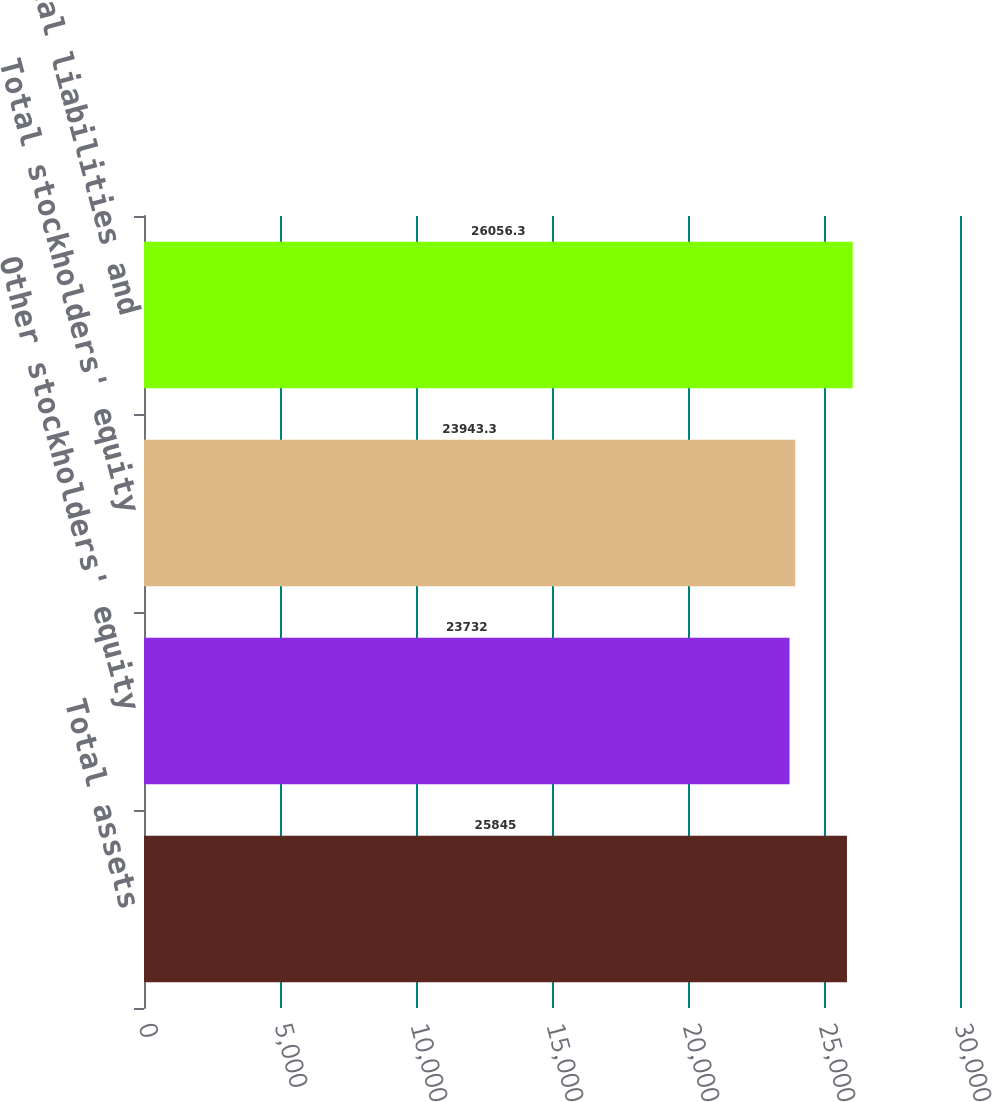Convert chart to OTSL. <chart><loc_0><loc_0><loc_500><loc_500><bar_chart><fcel>Total assets<fcel>Other stockholders' equity<fcel>Total stockholders' equity<fcel>Total liabilities and<nl><fcel>25845<fcel>23732<fcel>23943.3<fcel>26056.3<nl></chart> 